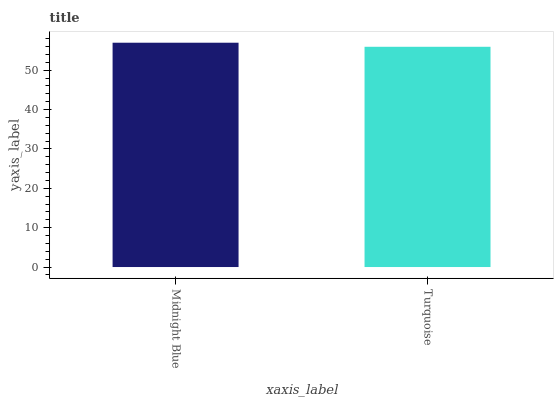Is Turquoise the minimum?
Answer yes or no. Yes. Is Midnight Blue the maximum?
Answer yes or no. Yes. Is Turquoise the maximum?
Answer yes or no. No. Is Midnight Blue greater than Turquoise?
Answer yes or no. Yes. Is Turquoise less than Midnight Blue?
Answer yes or no. Yes. Is Turquoise greater than Midnight Blue?
Answer yes or no. No. Is Midnight Blue less than Turquoise?
Answer yes or no. No. Is Midnight Blue the high median?
Answer yes or no. Yes. Is Turquoise the low median?
Answer yes or no. Yes. Is Turquoise the high median?
Answer yes or no. No. Is Midnight Blue the low median?
Answer yes or no. No. 